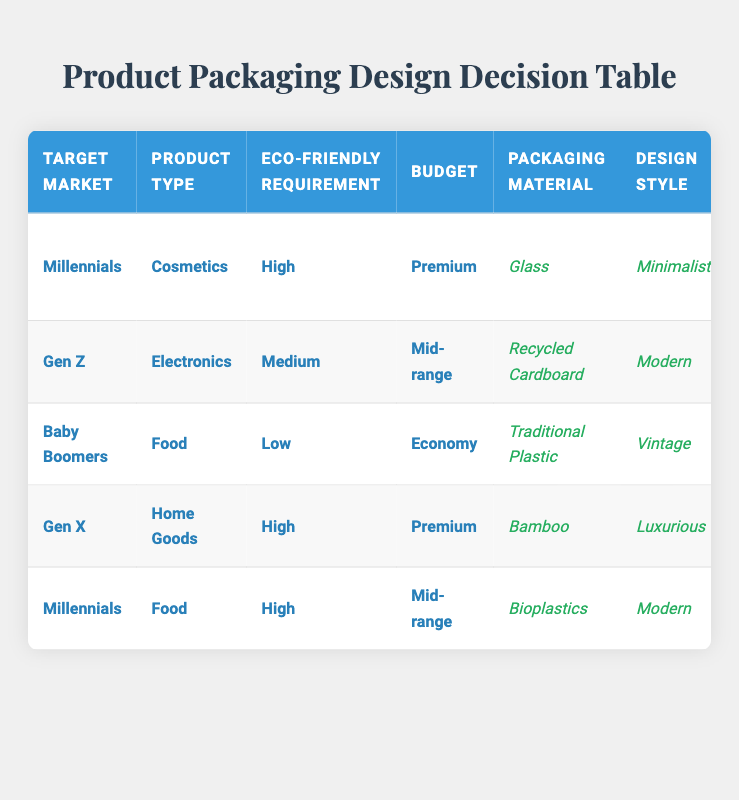What is the packaging material for Millennials' premium cosmetics products? The table states that for Millennials targeting premium cosmetics with a high eco-friendly requirement, the packaging material used is Glass.
Answer: Glass Which design style is used for mid-range food products aimed at Millennials? According to the table, the design style for mid-range food products aimed at Millennials with a high eco-friendly requirement is Modern.
Answer: Modern How many different packaging materials are mentioned in the table? The table includes six unique packaging materials: Glass, Recycled Cardboard, Traditional Plastic, Bamboo, Bioplastics, and Aluminum. Therefore, the total count is six.
Answer: Six Do Baby Boomers require eco-friendly packaging for low-budget food products? The table shows that for Baby Boomers' low-budget food products, the eco-friendly requirement is classified as Low. Thus, they do not require eco-friendly packaging.
Answer: No What is the additional feature for Gen Z electronics products with a medium eco-friendly requirement? The table indicates that for Gen Z electronics products with a medium requirement for eco-friendliness, the additional feature included is a QR Code for Product Info.
Answer: QR Code for Product Info Consider the eco-friendly requirements: are there any product types that utilize traditional plastic? The table specifies that Traditional Plastic is only used for Baby Boomers' food products which have a low eco-friendly requirement, indicating no other product types use traditional plastic.
Answer: Yes, only for Baby Boomers' food What is the average budget category for products aimed at Gen X and Millennials? The budget category for Gen X is Premium, and for Millennials, there are two categories: Mid-range and Premium. For the average calculation, Mid-range (assigned a value of 2) and Premium (value of 3) gives (2+3+3)/3 = 8/3. Thus, the average budget category is Mid-range.
Answer: Mid-range Which target market prefers a luxurious design style for high eco-friendly home goods? The table confirms that Gen X prefers a Luxurious design style for high eco-friendly home goods.
Answer: Gen X What color scheme is associated with high eco-friendly cosmetics intended for Millennials? According to the table, the color scheme associated with high eco-friendly cosmetics aimed at Millennials is Earth Tones.
Answer: Earth Tones 